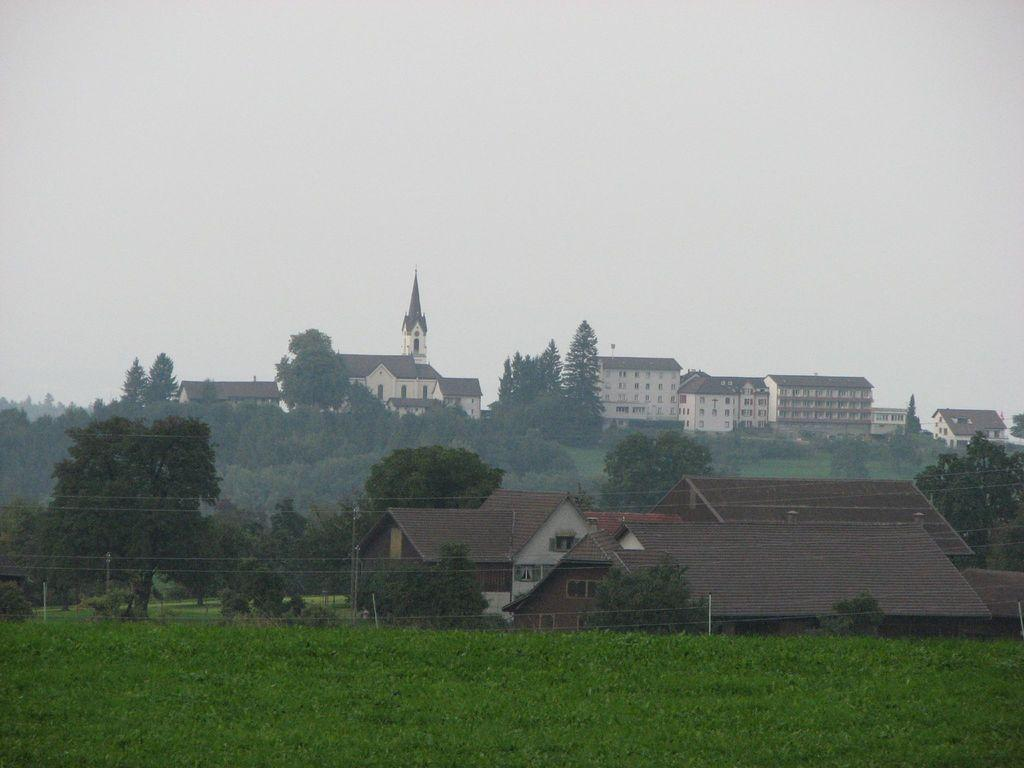What type of structures are visible in the image? There is a group of buildings in the image. What other natural elements can be seen in the image? There are trees in the image. What is located in the foreground of the image? In the foreground, there are plants and poles with wires. What is visible at the top of the image? The sky is visible at the top of the image. Can you tell me how many pizzas are being served at the sea in the image? There is no sea or pizzas present in the image. How do the buildings in the image plan to join the trees in the foreground? The buildings and trees in the image are not shown to be interacting or joining in any way. 